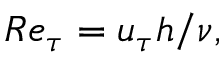Convert formula to latex. <formula><loc_0><loc_0><loc_500><loc_500>R e _ { \tau } = u _ { \tau } h / \nu ,</formula> 